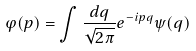<formula> <loc_0><loc_0><loc_500><loc_500>\varphi ( p ) = \int \frac { d q } { \sqrt { 2 \pi } } e ^ { - i p q } \psi ( q )</formula> 